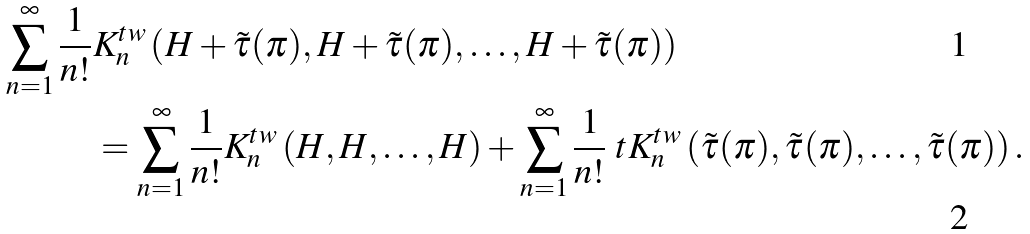Convert formula to latex. <formula><loc_0><loc_0><loc_500><loc_500>\sum _ { n = 1 } ^ { \infty } \frac { 1 } { n ! } & K ^ { t w } _ { n } \left ( H + \tilde { \tau } ( \pi ) , H + \tilde { \tau } ( \pi ) , \dots , H + \tilde { \tau } ( \pi ) \right ) \\ & = \sum _ { n = 1 } ^ { \infty } \frac { 1 } { n ! } K ^ { t w } _ { n } \left ( H , H , \dots , H \right ) + \sum _ { n = 1 } ^ { \infty } \frac { 1 } { n ! } \ t K ^ { t w } _ { n } \left ( \tilde { \tau } ( \pi ) , \tilde { \tau } ( \pi ) , \dots , \tilde { \tau } ( \pi ) \right ) .</formula> 